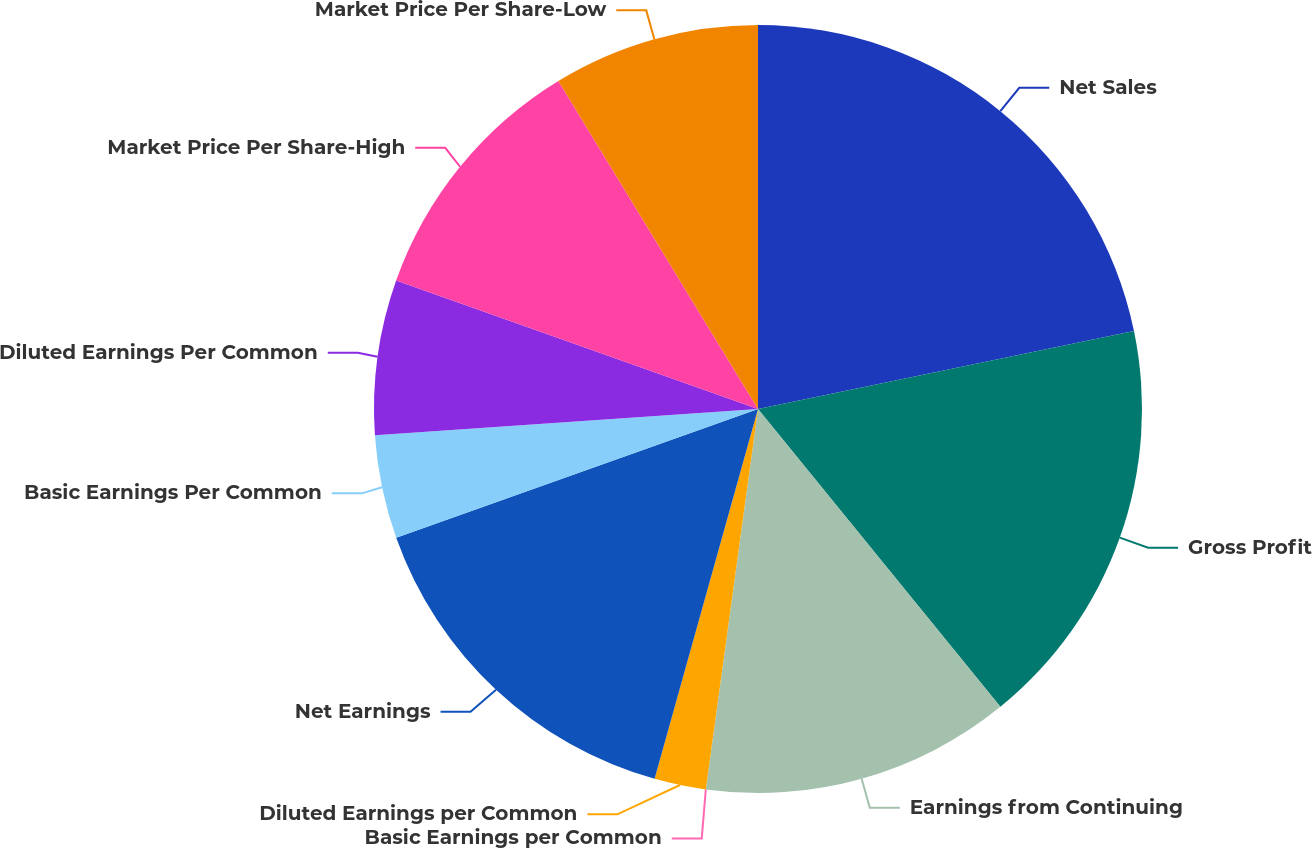<chart> <loc_0><loc_0><loc_500><loc_500><pie_chart><fcel>Net Sales<fcel>Gross Profit<fcel>Earnings from Continuing<fcel>Basic Earnings per Common<fcel>Diluted Earnings per Common<fcel>Net Earnings<fcel>Basic Earnings Per Common<fcel>Diluted Earnings Per Common<fcel>Market Price Per Share-High<fcel>Market Price Per Share-Low<nl><fcel>21.74%<fcel>17.39%<fcel>13.04%<fcel>0.0%<fcel>2.17%<fcel>15.22%<fcel>4.35%<fcel>6.52%<fcel>10.87%<fcel>8.7%<nl></chart> 